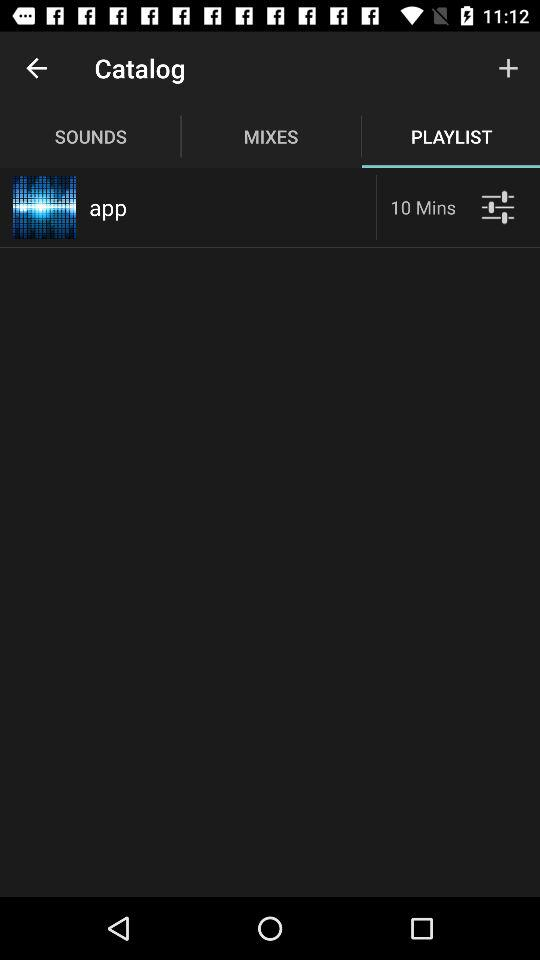Which option is selected in "Catalog"? The selected option in "Catalog" is "PLAYLIST". 